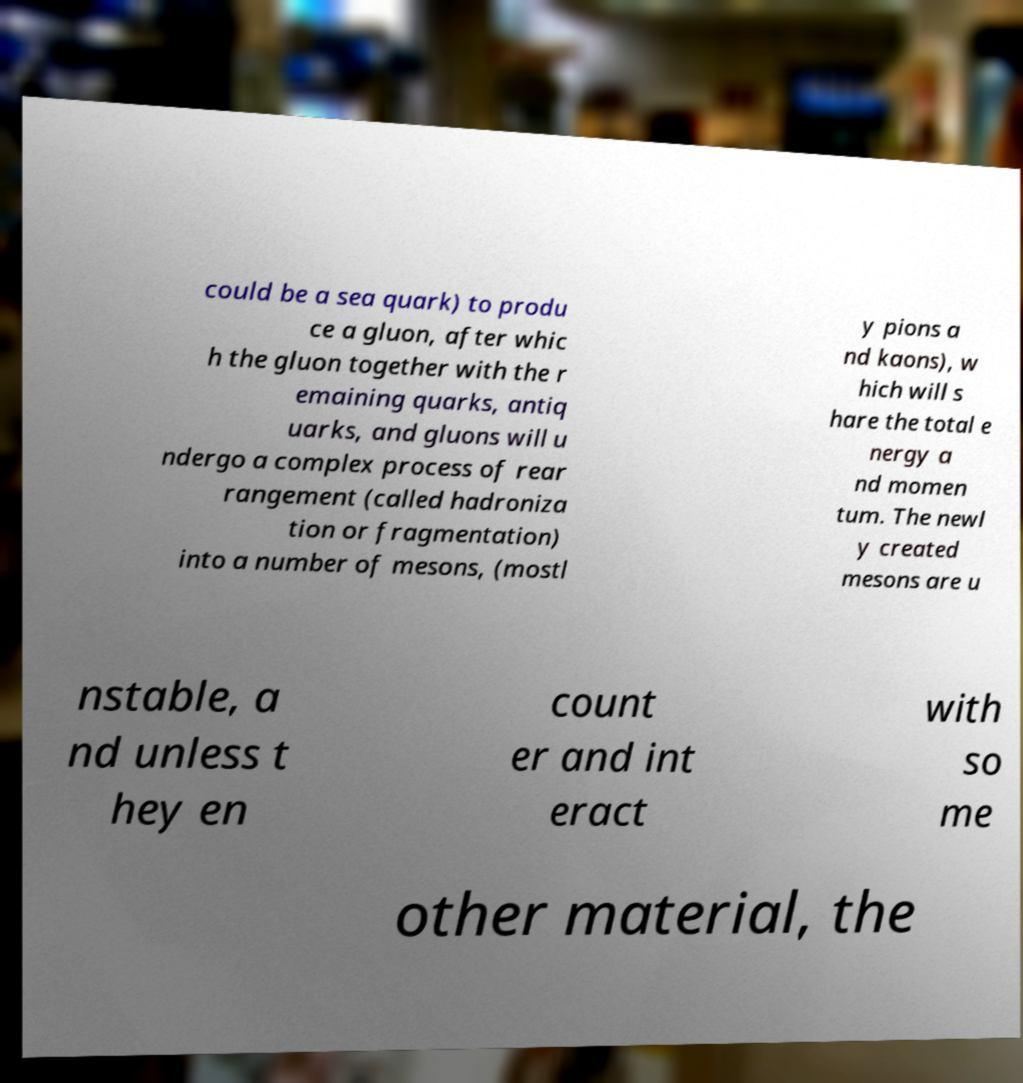Can you accurately transcribe the text from the provided image for me? could be a sea quark) to produ ce a gluon, after whic h the gluon together with the r emaining quarks, antiq uarks, and gluons will u ndergo a complex process of rear rangement (called hadroniza tion or fragmentation) into a number of mesons, (mostl y pions a nd kaons), w hich will s hare the total e nergy a nd momen tum. The newl y created mesons are u nstable, a nd unless t hey en count er and int eract with so me other material, the 